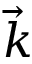<formula> <loc_0><loc_0><loc_500><loc_500>\vec { k }</formula> 